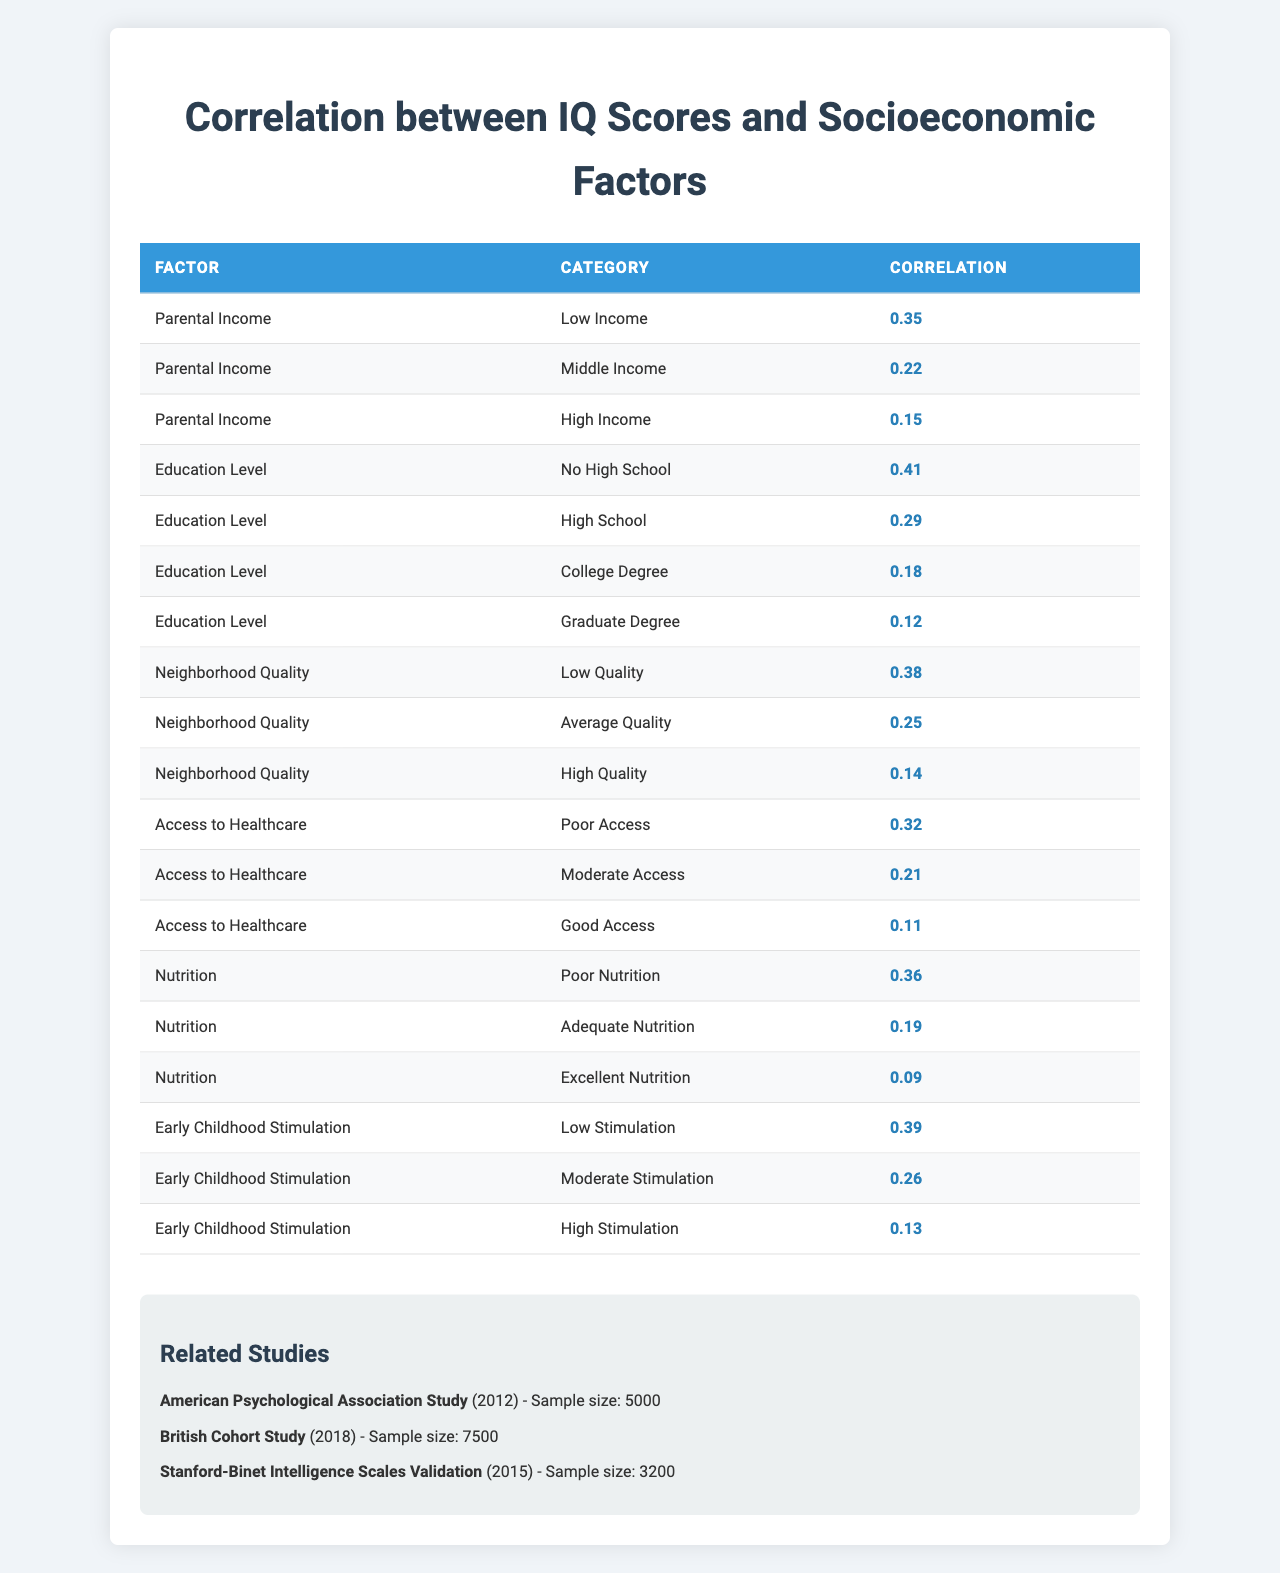What is the correlation between parental income and IQ for low-income individuals? The table shows that the correlation for low-income individuals is 0.35.
Answer: 0.35 Which socioeconomic factor has the highest correlation with IQ for individuals with no high school education? The factor with the highest correlation for this group is "Education Level," with a value of 0.41.
Answer: 0.41 What is the average correlation for high-income individuals across all factors? The correlations for high-income individuals are 0.15 (Parental Income), 0.18 (Education Level), 0.14 (Neighborhood Quality), 0.11 (Access to Healthcare), 0.09 (Nutrition), and 0.13 (Early Childhood Stimulation). The sum is 0.15 + 0.18 + 0.14 + 0.11 + 0.09 + 0.13 = 0.80, and dividing by 6 gives an average of 0.80/6 = 0.1333.
Answer: 0.13 Is the correlation between early childhood stimulation and IQ higher for moderate stimulation compared to adequate nutrition? The correlation for moderate childhood stimulation is 0.26 and for adequate nutrition is 0.19. Since 0.26 is greater than 0.19, the statement is true.
Answer: Yes Which socioeconomic factor shows the least correlation with IQ for high-quality neighborhoods? The table lists "Neighborhood Quality" for high-quality neighborhoods as 0.14, and it has the least correlation for that category.
Answer: 0.14 How does the correlation for poor nutrition compare to the correlation for poor access to healthcare? The correlation for poor nutrition is 0.36 and for poor access to healthcare is 0.32. Since 0.36 is greater than 0.32, poor nutrition has a higher correlation.
Answer: Poor nutrition is higher What is the difference between the correlations of early childhood stimulation for low stimulation and access to healthcare for poor access? The correlation for low stimulation in early childhood is 0.39 and for poor access to healthcare is 0.32. The difference is 0.39 - 0.32 = 0.07.
Answer: 0.07 Which factor has the second highest correlation for middle-income individuals and what is that value? The factor with the second highest correlation for middle-income individuals is "Education Level," with a value of 0.22, after "Parental Income" which is 0.22 itself.
Answer: Education Level, 0.22 Is there a trend where increasing socioeconomic conditions correlates with decreasing IQ scores in the data? The correlations for various factors generally decrease as socioeconomic conditions improve. For instance, high-income versus low-income shows decreasing numbers (0.15 vs. 0.35 for parental income). This suggests a trend of decreasing correlation with better conditions.
Answer: Yes What can you infer from the correlation values for all categories of the factors listed? The correlations tend to be higher in conditions labeled 'low' (e.g., low income, no high school education, low quality neighborhood) and decrease as conditions improve, suggesting that lower socioeconomic factors have a stronger association with IQ scores.
Answer: Lower factors correlate more strongly 